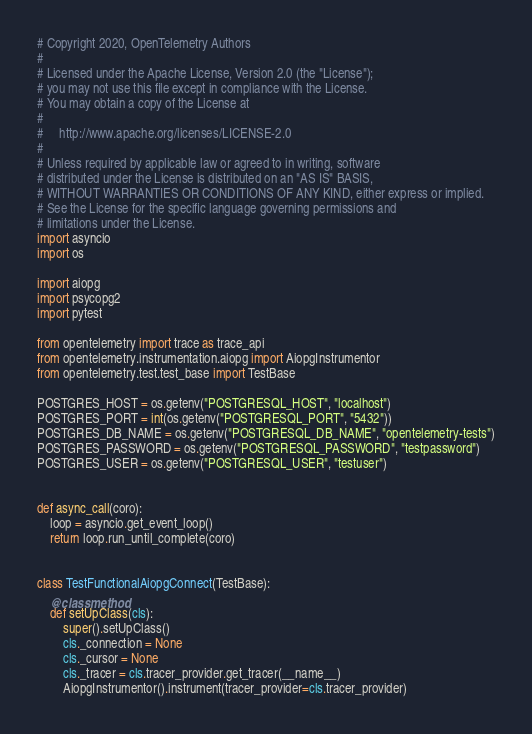<code> <loc_0><loc_0><loc_500><loc_500><_Python_># Copyright 2020, OpenTelemetry Authors
#
# Licensed under the Apache License, Version 2.0 (the "License");
# you may not use this file except in compliance with the License.
# You may obtain a copy of the License at
#
#     http://www.apache.org/licenses/LICENSE-2.0
#
# Unless required by applicable law or agreed to in writing, software
# distributed under the License is distributed on an "AS IS" BASIS,
# WITHOUT WARRANTIES OR CONDITIONS OF ANY KIND, either express or implied.
# See the License for the specific language governing permissions and
# limitations under the License.
import asyncio
import os

import aiopg
import psycopg2
import pytest

from opentelemetry import trace as trace_api
from opentelemetry.instrumentation.aiopg import AiopgInstrumentor
from opentelemetry.test.test_base import TestBase

POSTGRES_HOST = os.getenv("POSTGRESQL_HOST", "localhost")
POSTGRES_PORT = int(os.getenv("POSTGRESQL_PORT", "5432"))
POSTGRES_DB_NAME = os.getenv("POSTGRESQL_DB_NAME", "opentelemetry-tests")
POSTGRES_PASSWORD = os.getenv("POSTGRESQL_PASSWORD", "testpassword")
POSTGRES_USER = os.getenv("POSTGRESQL_USER", "testuser")


def async_call(coro):
    loop = asyncio.get_event_loop()
    return loop.run_until_complete(coro)


class TestFunctionalAiopgConnect(TestBase):
    @classmethod
    def setUpClass(cls):
        super().setUpClass()
        cls._connection = None
        cls._cursor = None
        cls._tracer = cls.tracer_provider.get_tracer(__name__)
        AiopgInstrumentor().instrument(tracer_provider=cls.tracer_provider)</code> 